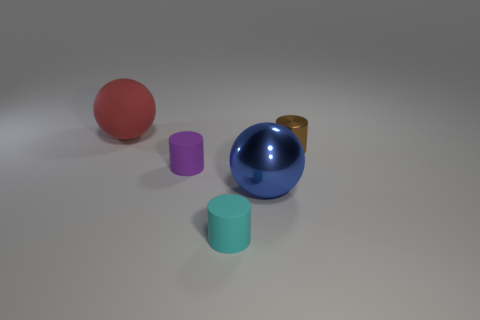Is the big sphere that is behind the brown metallic object made of the same material as the large sphere that is to the right of the tiny purple matte cylinder?
Your answer should be compact. No. There is a tiny cylinder right of the cyan matte thing; what material is it?
Make the answer very short. Metal. What number of shiny objects are big blue spheres or purple cylinders?
Offer a terse response. 1. The big sphere that is in front of the sphere that is to the left of the cyan rubber thing is what color?
Your answer should be compact. Blue. Are the tiny purple cylinder and the tiny brown thing that is right of the big red ball made of the same material?
Give a very brief answer. No. What is the color of the tiny object that is left of the tiny cyan matte thing to the left of the cylinder right of the big blue thing?
Provide a succinct answer. Purple. Is there anything else that has the same shape as the small metallic thing?
Offer a terse response. Yes. Is the number of tiny gray cylinders greater than the number of cyan things?
Your response must be concise. No. How many small cylinders are on the right side of the metal sphere and in front of the large blue metallic object?
Provide a succinct answer. 0. There is a tiny brown cylinder that is behind the small purple matte thing; what number of big red matte things are behind it?
Offer a terse response. 1. 